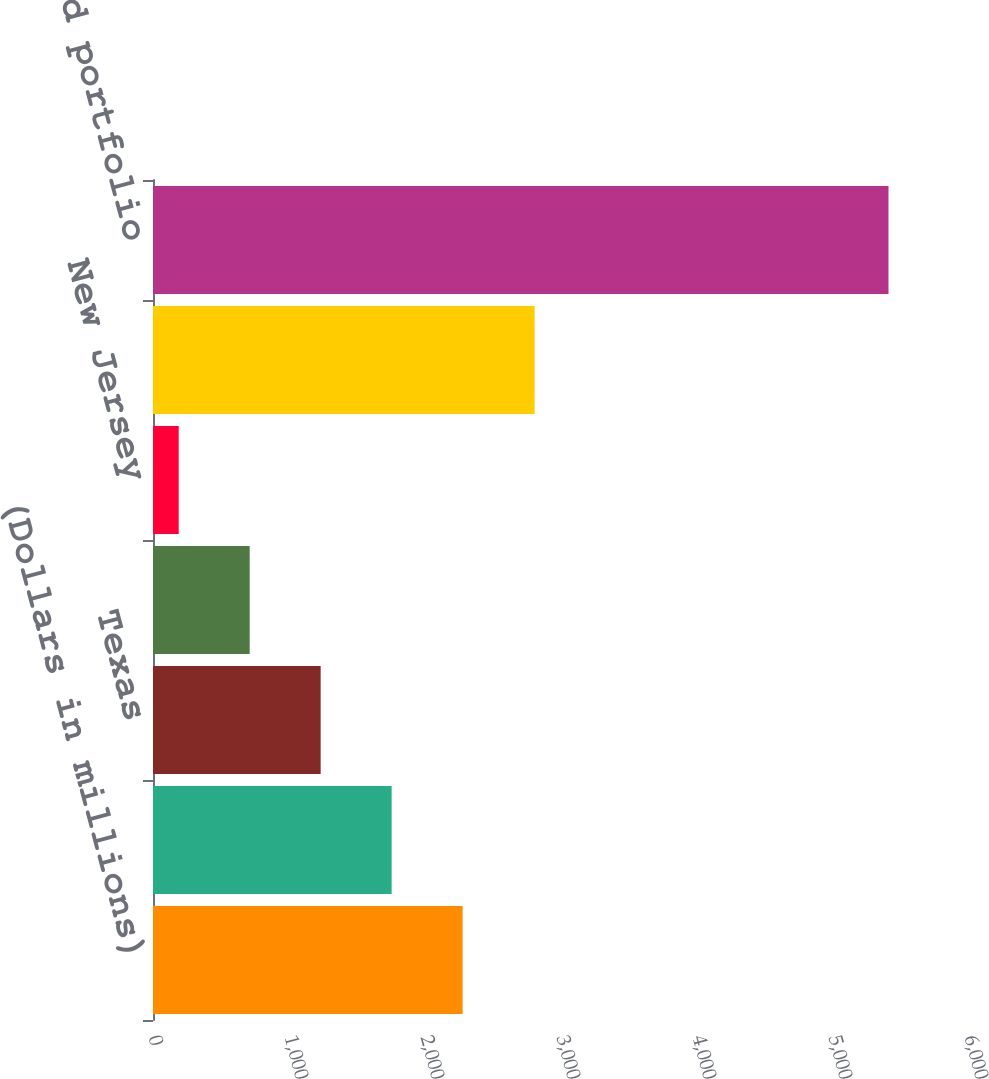Convert chart to OTSL. <chart><loc_0><loc_0><loc_500><loc_500><bar_chart><fcel>(Dollars in millions)<fcel>Florida<fcel>Texas<fcel>New York<fcel>New Jersey<fcel>Other US<fcel>Total US credit card portfolio<nl><fcel>2276.6<fcel>1754.7<fcel>1232.8<fcel>710.9<fcel>189<fcel>2806<fcel>5408<nl></chart> 